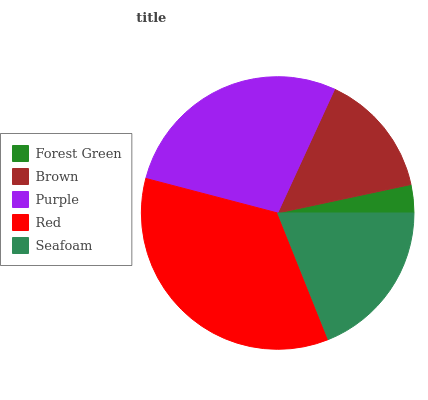Is Forest Green the minimum?
Answer yes or no. Yes. Is Red the maximum?
Answer yes or no. Yes. Is Brown the minimum?
Answer yes or no. No. Is Brown the maximum?
Answer yes or no. No. Is Brown greater than Forest Green?
Answer yes or no. Yes. Is Forest Green less than Brown?
Answer yes or no. Yes. Is Forest Green greater than Brown?
Answer yes or no. No. Is Brown less than Forest Green?
Answer yes or no. No. Is Seafoam the high median?
Answer yes or no. Yes. Is Seafoam the low median?
Answer yes or no. Yes. Is Forest Green the high median?
Answer yes or no. No. Is Brown the low median?
Answer yes or no. No. 